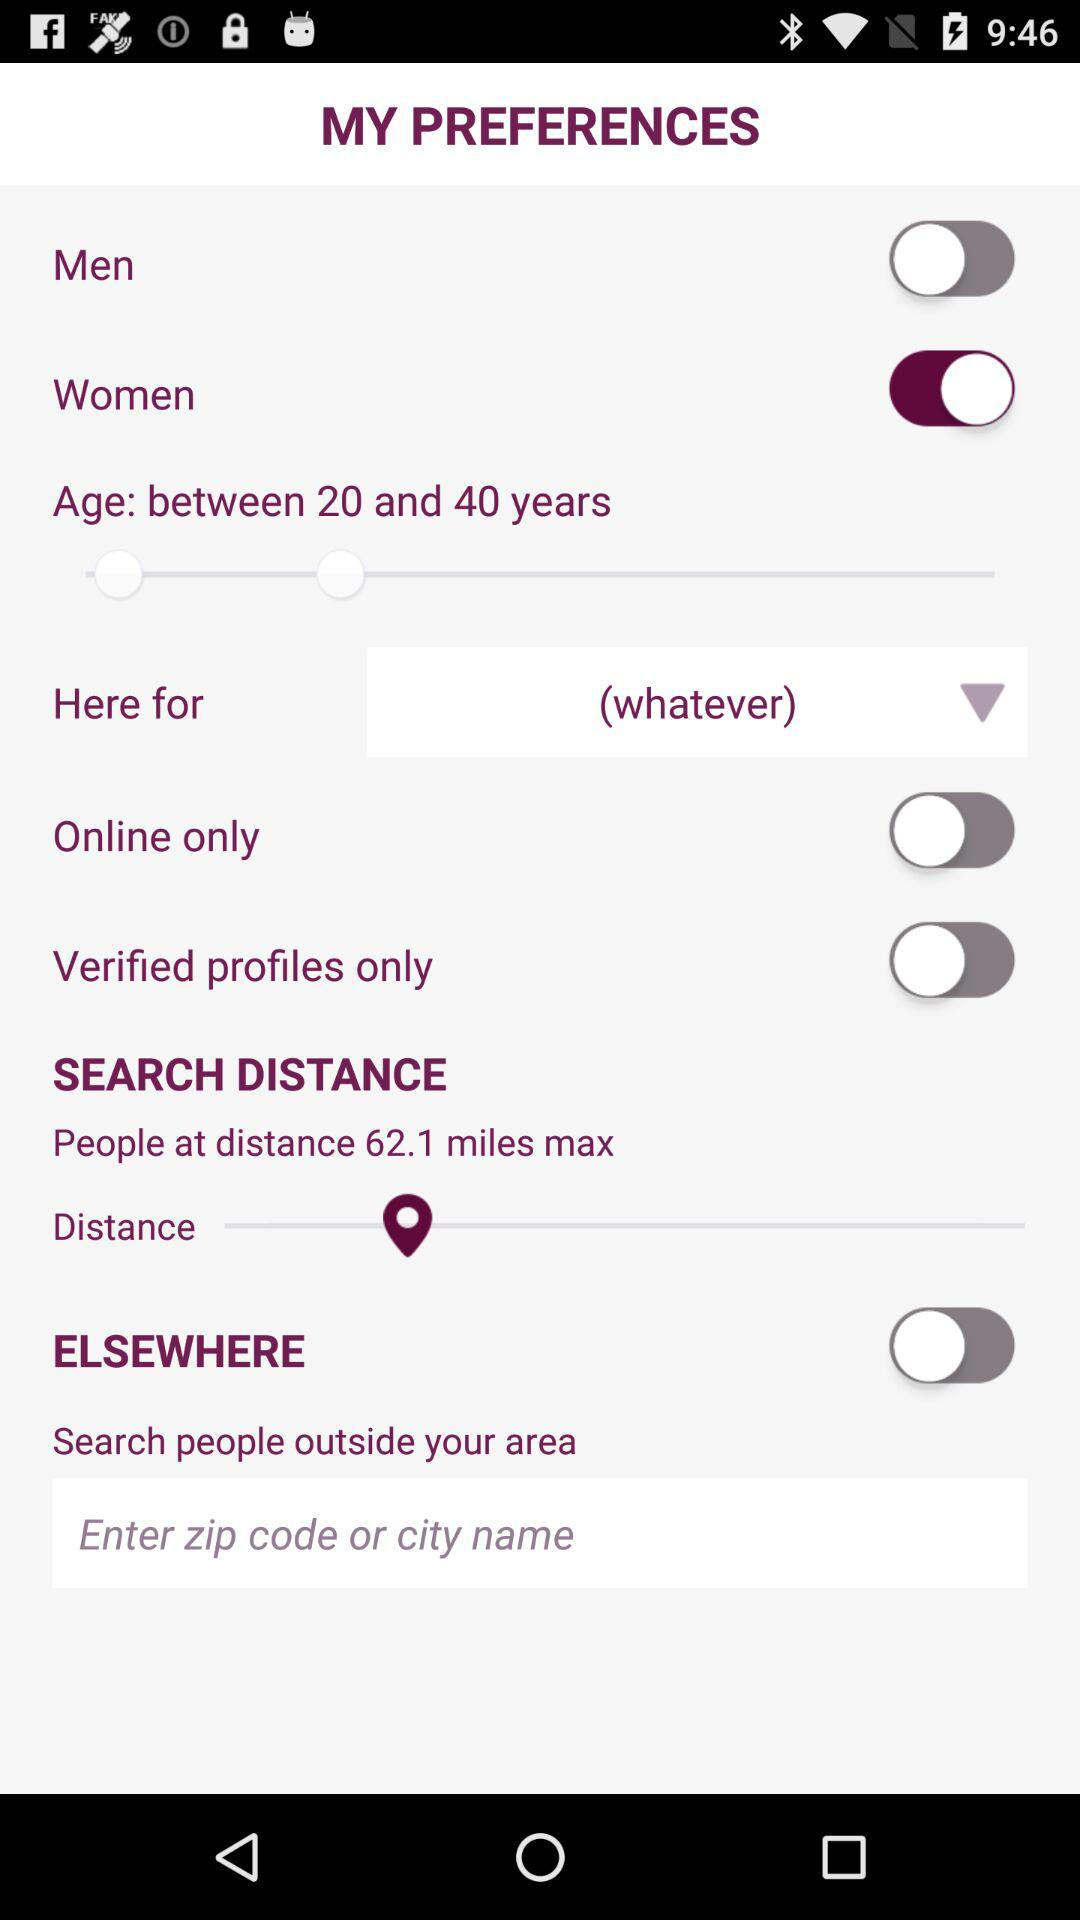How many options are there that allow you to filter by the person's location?
Answer the question using a single word or phrase. 3 